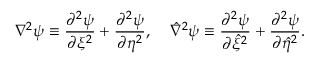Convert formula to latex. <formula><loc_0><loc_0><loc_500><loc_500>\nabla ^ { 2 } \psi \equiv \frac { \partial ^ { 2 } \psi } { \partial \xi ^ { 2 } } + \frac { \partial ^ { 2 } \psi } { \partial \eta ^ { 2 } } , \, \hat { \nabla } ^ { 2 } \psi \equiv \frac { \partial ^ { 2 } \psi } { \partial \hat { \xi } ^ { 2 } } + \frac { \partial ^ { 2 } \psi } { \partial \hat { \eta } ^ { 2 } } .</formula> 